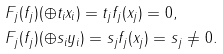<formula> <loc_0><loc_0><loc_500><loc_500>& F _ { j } ( f _ { j } ) ( \oplus t _ { i } x _ { i } ) = t _ { j } f _ { j } ( x _ { j } ) = 0 , \\ & F _ { j } ( f _ { j } ) ( \oplus s _ { i } y _ { i } ) = s _ { j } f _ { j } ( x _ { j } ) = s _ { j } \neq 0 .</formula> 